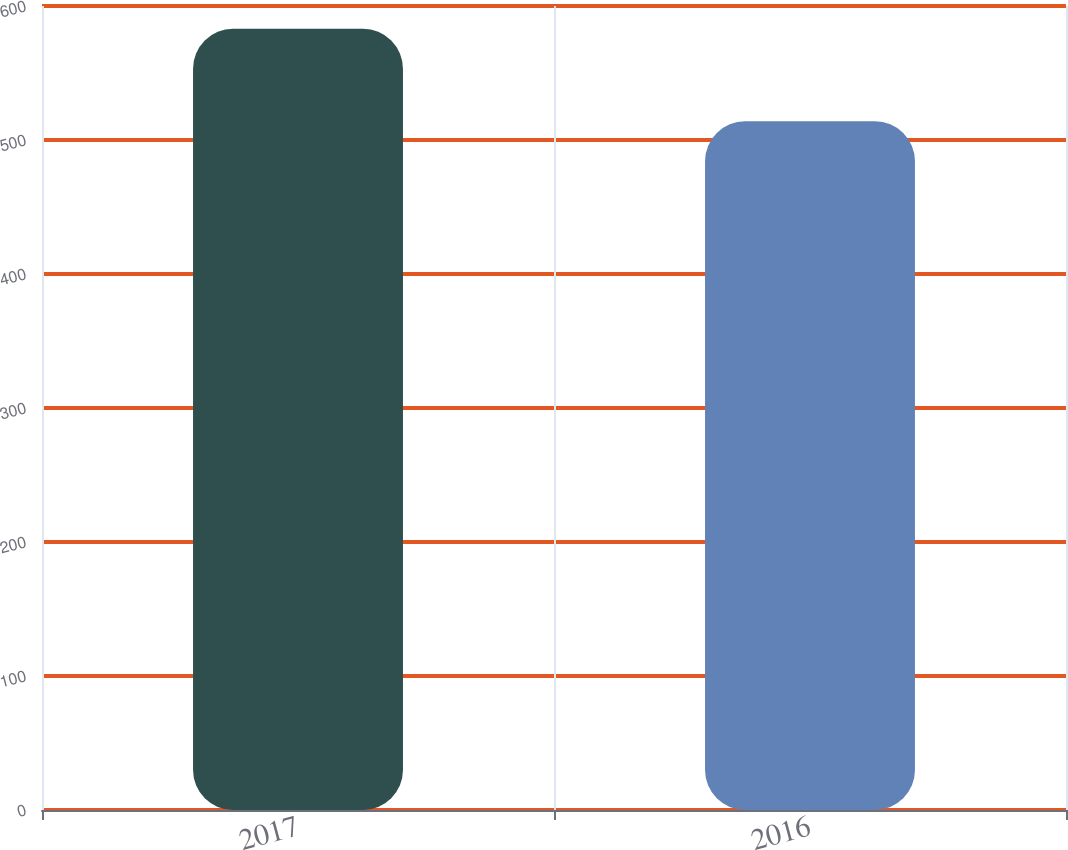Convert chart. <chart><loc_0><loc_0><loc_500><loc_500><bar_chart><fcel>2017<fcel>2016<nl><fcel>583<fcel>514<nl></chart> 